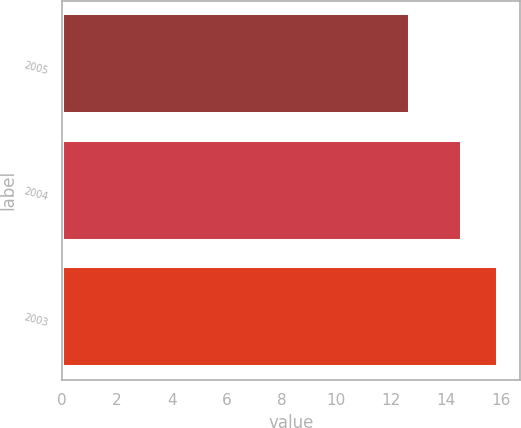Convert chart. <chart><loc_0><loc_0><loc_500><loc_500><bar_chart><fcel>2005<fcel>2004<fcel>2003<nl><fcel>12.7<fcel>14.6<fcel>15.9<nl></chart> 